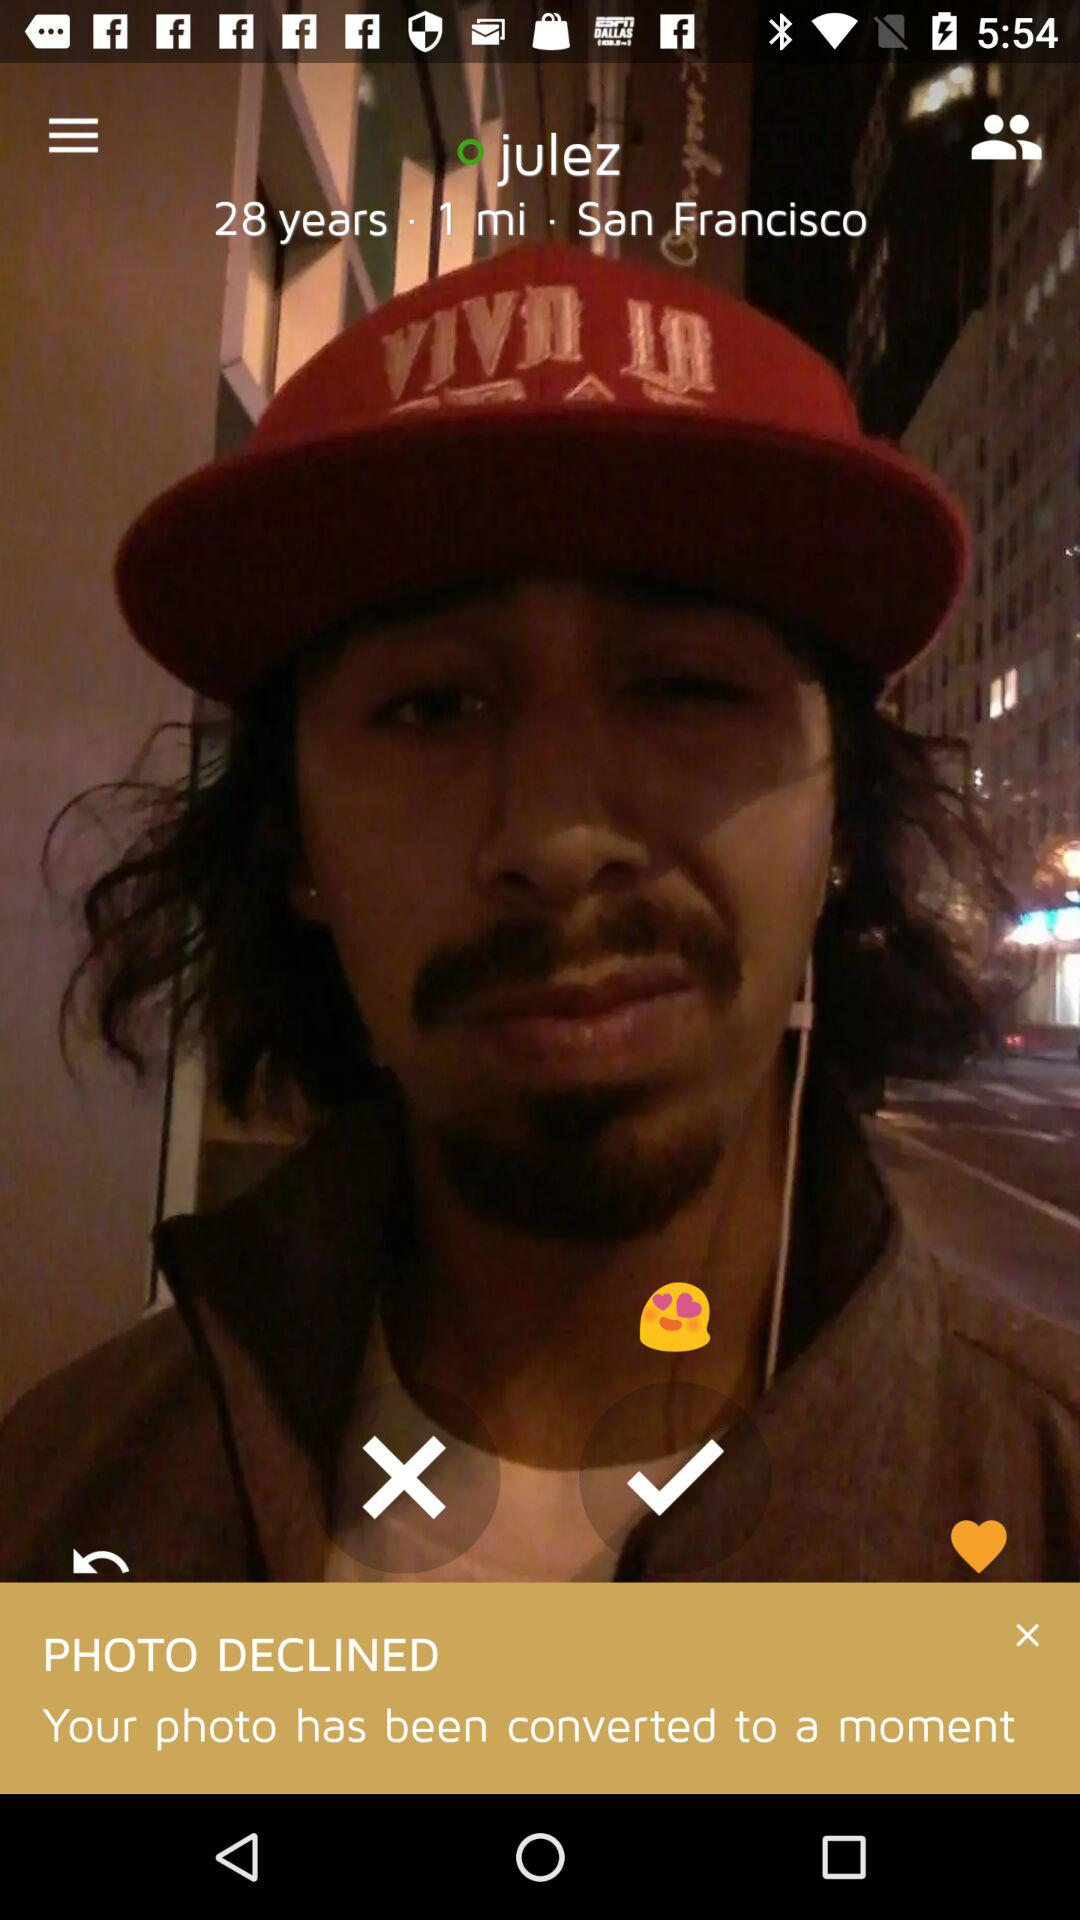What is the name of the person? The name of the person is Julez. 